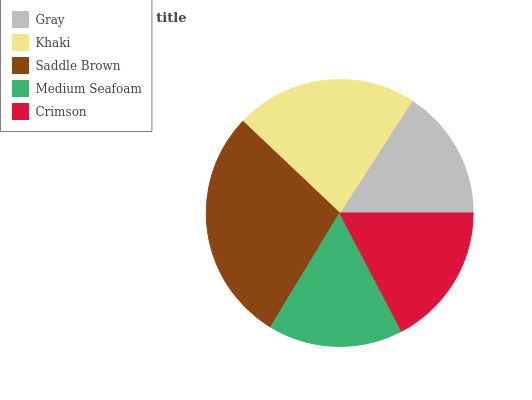Is Gray the minimum?
Answer yes or no. Yes. Is Saddle Brown the maximum?
Answer yes or no. Yes. Is Khaki the minimum?
Answer yes or no. No. Is Khaki the maximum?
Answer yes or no. No. Is Khaki greater than Gray?
Answer yes or no. Yes. Is Gray less than Khaki?
Answer yes or no. Yes. Is Gray greater than Khaki?
Answer yes or no. No. Is Khaki less than Gray?
Answer yes or no. No. Is Crimson the high median?
Answer yes or no. Yes. Is Crimson the low median?
Answer yes or no. Yes. Is Khaki the high median?
Answer yes or no. No. Is Khaki the low median?
Answer yes or no. No. 